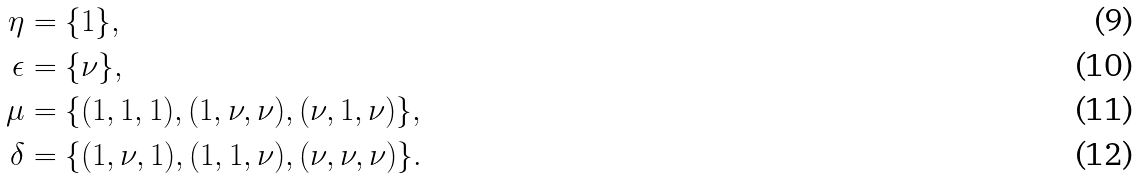<formula> <loc_0><loc_0><loc_500><loc_500>\eta & = \{ 1 \} , \\ \epsilon & = \{ \nu \} , \\ \mu & = \{ ( 1 , 1 , 1 ) , ( 1 , \nu , \nu ) , ( \nu , 1 , \nu ) \} , \\ \delta & = \{ ( 1 , \nu , 1 ) , ( 1 , 1 , \nu ) , ( \nu , \nu , \nu ) \} .</formula> 